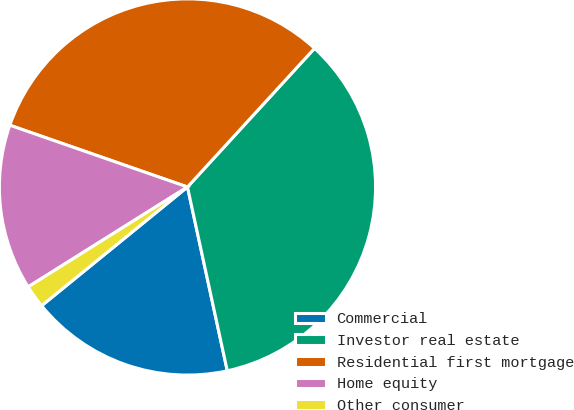<chart> <loc_0><loc_0><loc_500><loc_500><pie_chart><fcel>Commercial<fcel>Investor real estate<fcel>Residential first mortgage<fcel>Home equity<fcel>Other consumer<nl><fcel>17.52%<fcel>34.8%<fcel>31.48%<fcel>14.24%<fcel>1.96%<nl></chart> 